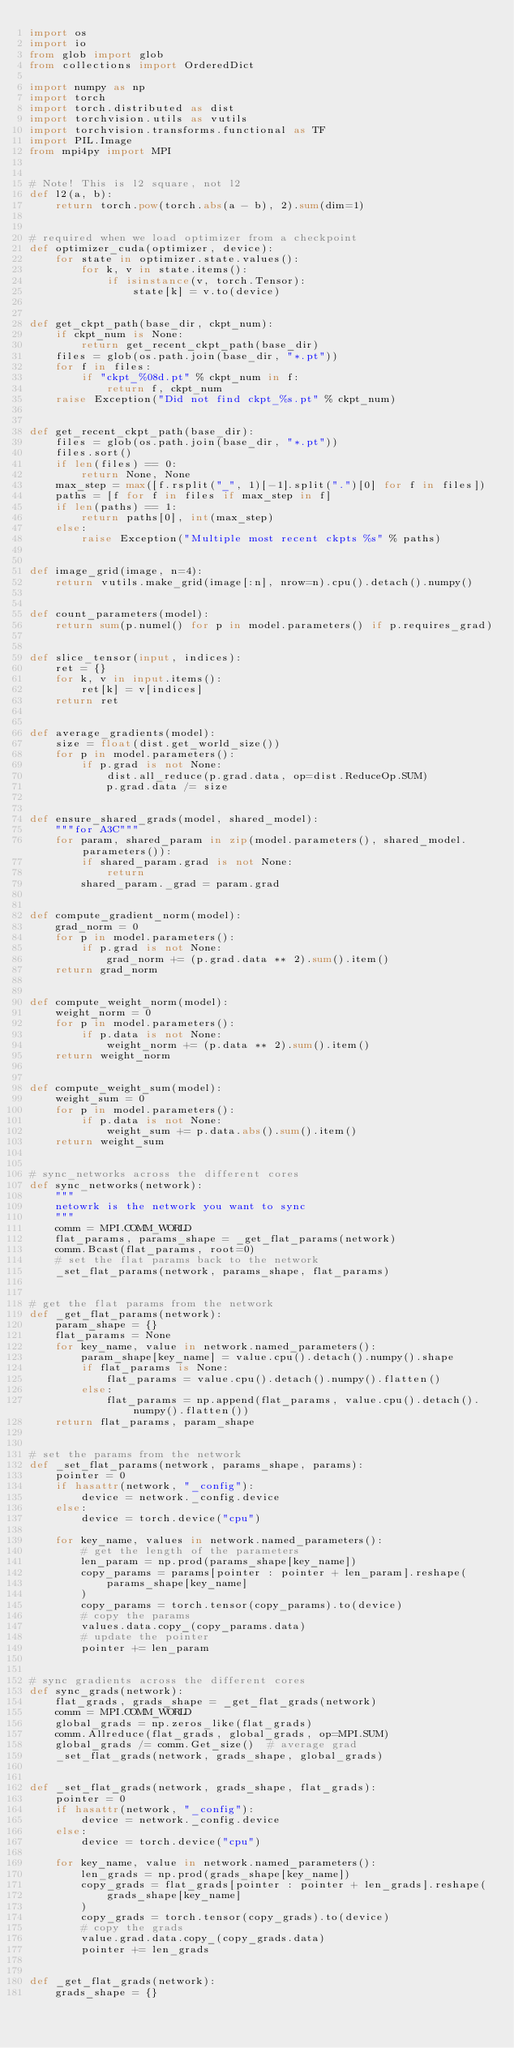<code> <loc_0><loc_0><loc_500><loc_500><_Python_>import os
import io
from glob import glob
from collections import OrderedDict

import numpy as np
import torch
import torch.distributed as dist
import torchvision.utils as vutils
import torchvision.transforms.functional as TF
import PIL.Image
from mpi4py import MPI


# Note! This is l2 square, not l2
def l2(a, b):
    return torch.pow(torch.abs(a - b), 2).sum(dim=1)


# required when we load optimizer from a checkpoint
def optimizer_cuda(optimizer, device):
    for state in optimizer.state.values():
        for k, v in state.items():
            if isinstance(v, torch.Tensor):
                state[k] = v.to(device)


def get_ckpt_path(base_dir, ckpt_num):
    if ckpt_num is None:
        return get_recent_ckpt_path(base_dir)
    files = glob(os.path.join(base_dir, "*.pt"))
    for f in files:
        if "ckpt_%08d.pt" % ckpt_num in f:
            return f, ckpt_num
    raise Exception("Did not find ckpt_%s.pt" % ckpt_num)


def get_recent_ckpt_path(base_dir):
    files = glob(os.path.join(base_dir, "*.pt"))
    files.sort()
    if len(files) == 0:
        return None, None
    max_step = max([f.rsplit("_", 1)[-1].split(".")[0] for f in files])
    paths = [f for f in files if max_step in f]
    if len(paths) == 1:
        return paths[0], int(max_step)
    else:
        raise Exception("Multiple most recent ckpts %s" % paths)


def image_grid(image, n=4):
    return vutils.make_grid(image[:n], nrow=n).cpu().detach().numpy()


def count_parameters(model):
    return sum(p.numel() for p in model.parameters() if p.requires_grad)


def slice_tensor(input, indices):
    ret = {}
    for k, v in input.items():
        ret[k] = v[indices]
    return ret


def average_gradients(model):
    size = float(dist.get_world_size())
    for p in model.parameters():
        if p.grad is not None:
            dist.all_reduce(p.grad.data, op=dist.ReduceOp.SUM)
            p.grad.data /= size


def ensure_shared_grads(model, shared_model):
    """for A3C"""
    for param, shared_param in zip(model.parameters(), shared_model.parameters()):
        if shared_param.grad is not None:
            return
        shared_param._grad = param.grad


def compute_gradient_norm(model):
    grad_norm = 0
    for p in model.parameters():
        if p.grad is not None:
            grad_norm += (p.grad.data ** 2).sum().item()
    return grad_norm


def compute_weight_norm(model):
    weight_norm = 0
    for p in model.parameters():
        if p.data is not None:
            weight_norm += (p.data ** 2).sum().item()
    return weight_norm


def compute_weight_sum(model):
    weight_sum = 0
    for p in model.parameters():
        if p.data is not None:
            weight_sum += p.data.abs().sum().item()
    return weight_sum


# sync_networks across the different cores
def sync_networks(network):
    """
    netowrk is the network you want to sync
    """
    comm = MPI.COMM_WORLD
    flat_params, params_shape = _get_flat_params(network)
    comm.Bcast(flat_params, root=0)
    # set the flat params back to the network
    _set_flat_params(network, params_shape, flat_params)


# get the flat params from the network
def _get_flat_params(network):
    param_shape = {}
    flat_params = None
    for key_name, value in network.named_parameters():
        param_shape[key_name] = value.cpu().detach().numpy().shape
        if flat_params is None:
            flat_params = value.cpu().detach().numpy().flatten()
        else:
            flat_params = np.append(flat_params, value.cpu().detach().numpy().flatten())
    return flat_params, param_shape


# set the params from the network
def _set_flat_params(network, params_shape, params):
    pointer = 0
    if hasattr(network, "_config"):
        device = network._config.device
    else:
        device = torch.device("cpu")

    for key_name, values in network.named_parameters():
        # get the length of the parameters
        len_param = np.prod(params_shape[key_name])
        copy_params = params[pointer : pointer + len_param].reshape(
            params_shape[key_name]
        )
        copy_params = torch.tensor(copy_params).to(device)
        # copy the params
        values.data.copy_(copy_params.data)
        # update the pointer
        pointer += len_param


# sync gradients across the different cores
def sync_grads(network):
    flat_grads, grads_shape = _get_flat_grads(network)
    comm = MPI.COMM_WORLD
    global_grads = np.zeros_like(flat_grads)
    comm.Allreduce(flat_grads, global_grads, op=MPI.SUM)
    global_grads /= comm.Get_size()  # average grad
    _set_flat_grads(network, grads_shape, global_grads)


def _set_flat_grads(network, grads_shape, flat_grads):
    pointer = 0
    if hasattr(network, "_config"):
        device = network._config.device
    else:
        device = torch.device("cpu")

    for key_name, value in network.named_parameters():
        len_grads = np.prod(grads_shape[key_name])
        copy_grads = flat_grads[pointer : pointer + len_grads].reshape(
            grads_shape[key_name]
        )
        copy_grads = torch.tensor(copy_grads).to(device)
        # copy the grads
        value.grad.data.copy_(copy_grads.data)
        pointer += len_grads


def _get_flat_grads(network):
    grads_shape = {}</code> 